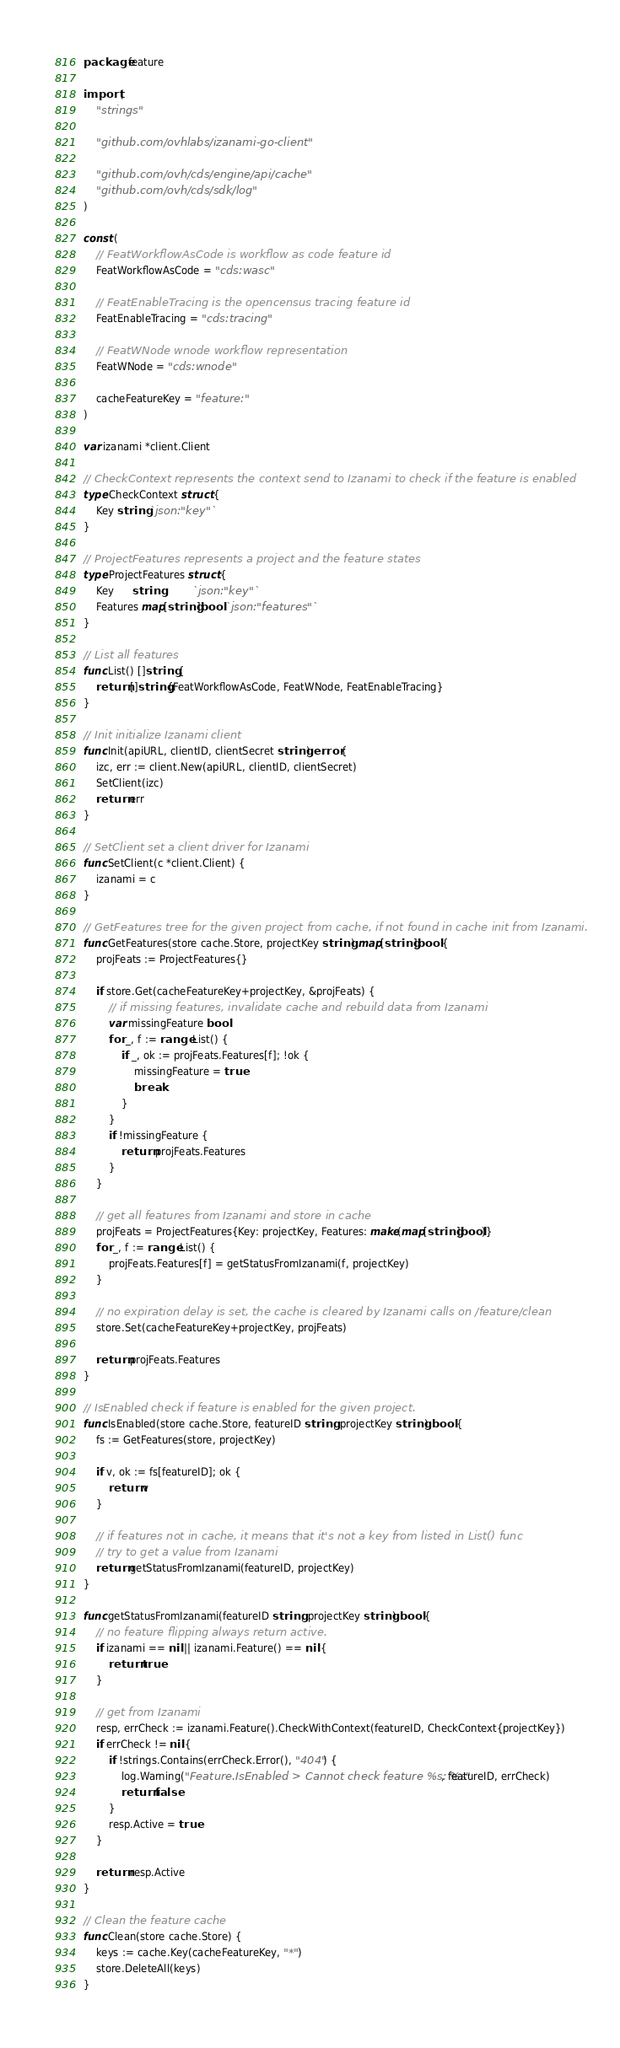Convert code to text. <code><loc_0><loc_0><loc_500><loc_500><_Go_>package feature

import (
	"strings"

	"github.com/ovhlabs/izanami-go-client"

	"github.com/ovh/cds/engine/api/cache"
	"github.com/ovh/cds/sdk/log"
)

const (
	// FeatWorkflowAsCode is workflow as code feature id
	FeatWorkflowAsCode = "cds:wasc"

	// FeatEnableTracing is the opencensus tracing feature id
	FeatEnableTracing = "cds:tracing"

	// FeatWNode wnode workflow representation
	FeatWNode = "cds:wnode"

	cacheFeatureKey = "feature:"
)

var izanami *client.Client

// CheckContext represents the context send to Izanami to check if the feature is enabled
type CheckContext struct {
	Key string `json:"key"`
}

// ProjectFeatures represents a project and the feature states
type ProjectFeatures struct {
	Key      string          `json:"key"`
	Features map[string]bool `json:"features"`
}

// List all features
func List() []string {
	return []string{FeatWorkflowAsCode, FeatWNode, FeatEnableTracing}
}

// Init initialize Izanami client
func Init(apiURL, clientID, clientSecret string) error {
	izc, err := client.New(apiURL, clientID, clientSecret)
	SetClient(izc)
	return err
}

// SetClient set a client driver for Izanami
func SetClient(c *client.Client) {
	izanami = c
}

// GetFeatures tree for the given project from cache, if not found in cache init from Izanami.
func GetFeatures(store cache.Store, projectKey string) map[string]bool {
	projFeats := ProjectFeatures{}

	if store.Get(cacheFeatureKey+projectKey, &projFeats) {
		// if missing features, invalidate cache and rebuild data from Izanami
		var missingFeature bool
		for _, f := range List() {
			if _, ok := projFeats.Features[f]; !ok {
				missingFeature = true
				break
			}
		}
		if !missingFeature {
			return projFeats.Features
		}
	}

	// get all features from Izanami and store in cache
	projFeats = ProjectFeatures{Key: projectKey, Features: make(map[string]bool)}
	for _, f := range List() {
		projFeats.Features[f] = getStatusFromIzanami(f, projectKey)
	}

	// no expiration delay is set, the cache is cleared by Izanami calls on /feature/clean
	store.Set(cacheFeatureKey+projectKey, projFeats)

	return projFeats.Features
}

// IsEnabled check if feature is enabled for the given project.
func IsEnabled(store cache.Store, featureID string, projectKey string) bool {
	fs := GetFeatures(store, projectKey)

	if v, ok := fs[featureID]; ok {
		return v
	}

	// if features not in cache, it means that it's not a key from listed in List() func
	// try to get a value from Izanami
	return getStatusFromIzanami(featureID, projectKey)
}

func getStatusFromIzanami(featureID string, projectKey string) bool {
	// no feature flipping always return active.
	if izanami == nil || izanami.Feature() == nil {
		return true
	}

	// get from Izanami
	resp, errCheck := izanami.Feature().CheckWithContext(featureID, CheckContext{projectKey})
	if errCheck != nil {
		if !strings.Contains(errCheck.Error(), "404") {
			log.Warning("Feature.IsEnabled > Cannot check feature %s: %s", featureID, errCheck)
			return false
		}
		resp.Active = true
	}

	return resp.Active
}

// Clean the feature cache
func Clean(store cache.Store) {
	keys := cache.Key(cacheFeatureKey, "*")
	store.DeleteAll(keys)
}
</code> 